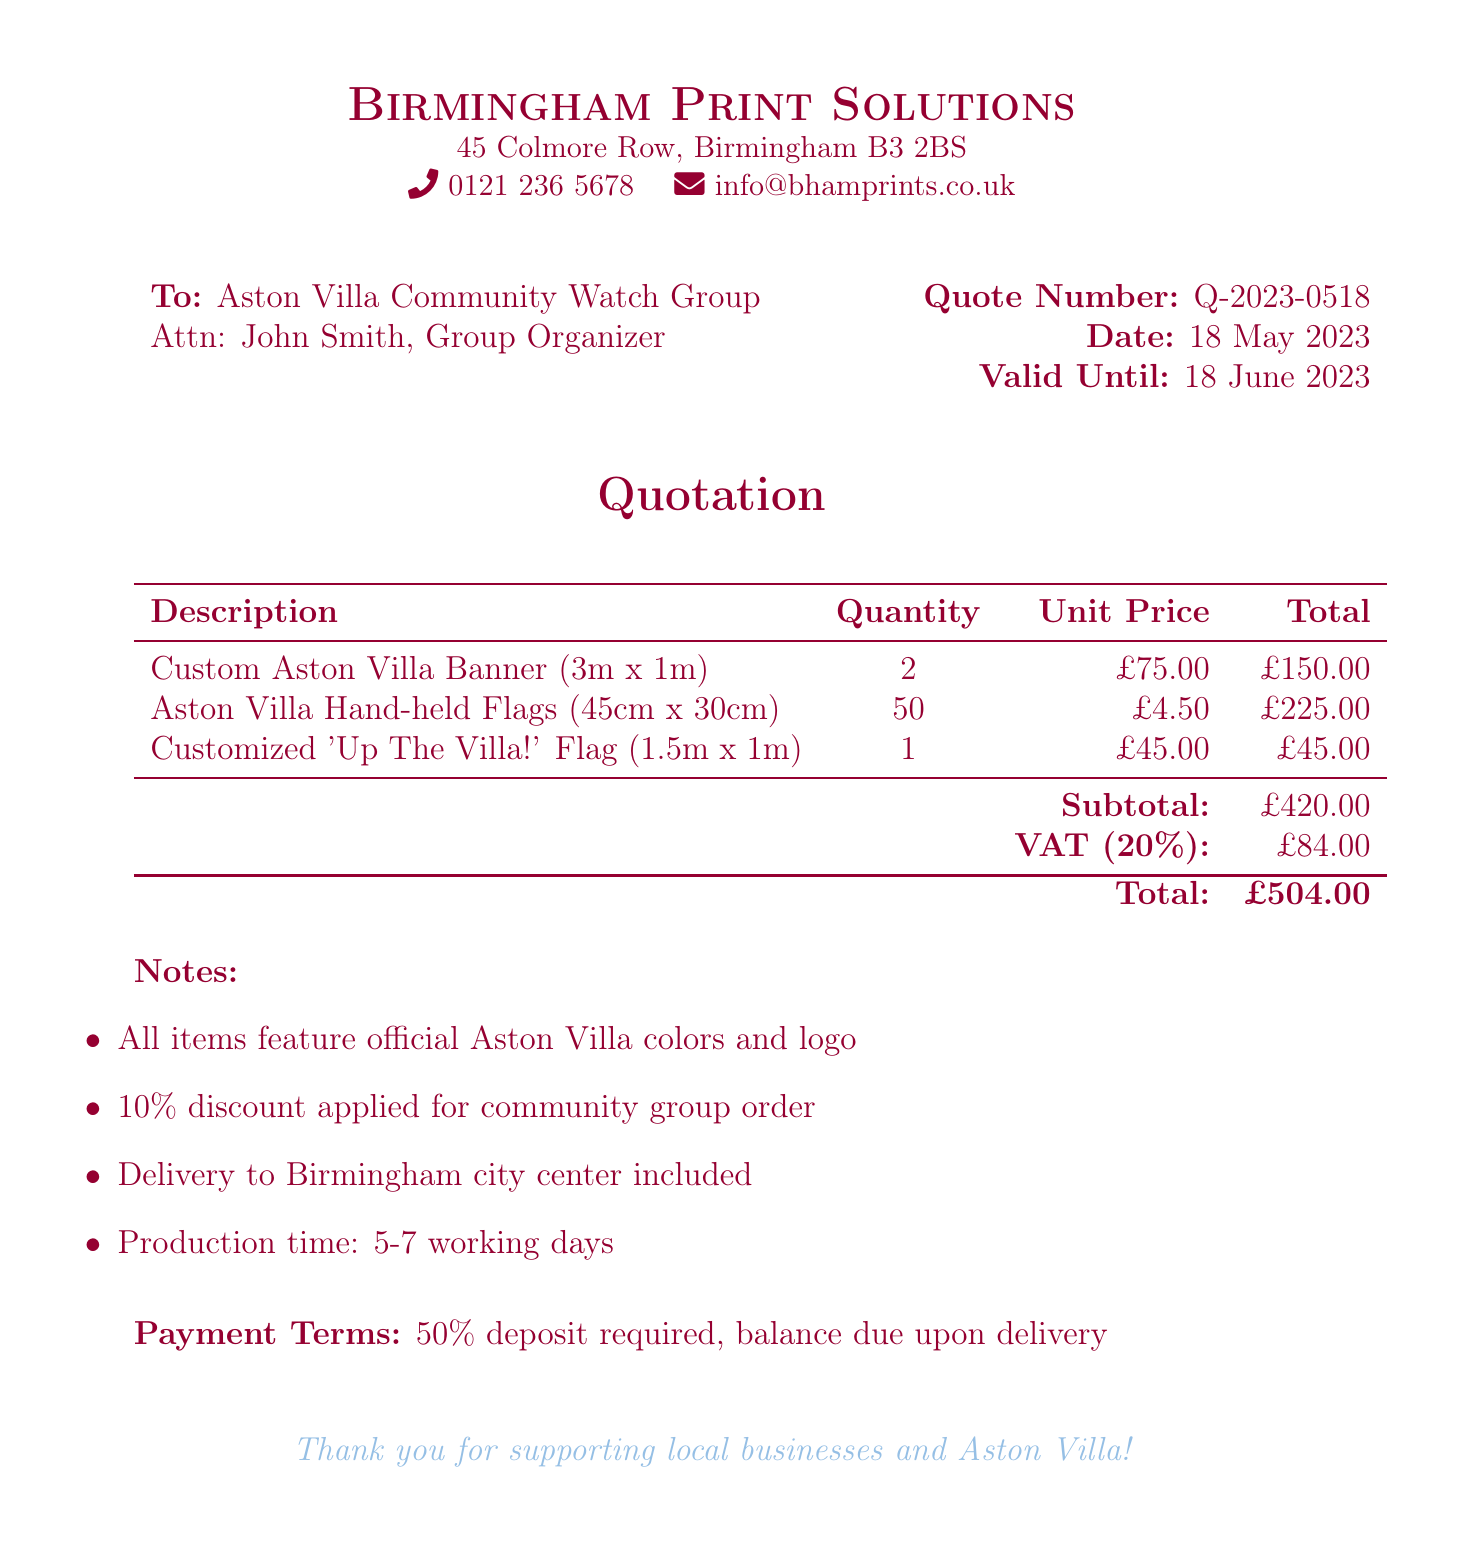What is the quote number? The quote number is stated at the top of the quotation section and identifies this specific quote.
Answer: Q-2023-0518 Who is the quote addressed to? The quote is addressed to the Aston Villa Community Watch Group, specifically to John Smith, the group organizer.
Answer: Aston Villa Community Watch Group What is the subtotal amount? The subtotal amount is listed before the VAT is calculated and is the sum of the total costs of the items.
Answer: £420.00 What percentage is the VAT? The VAT percentage is explicitly mentioned in the document, indicating the rate applied to the subtotal.
Answer: 20% How many hand-held flags are being ordered? The quantity of hand-held flags is clearly specified in the list of items for the order.
Answer: 50 What is the total cost including VAT? The total cost combines the subtotal and the VAT, which is provided at the bottom of the pricing table.
Answer: £504.00 What is the production time stated in the document? The production time is mentioned in the notes section and indicates how long it will take to produce the items.
Answer: 5-7 working days What discount rate was applied to the order? The discount rate is mentioned as a note in the quotation and reflects a special offering for community organizations.
Answer: 10% What is the delivery location for the order? The delivery location is specified in the notes and indicates where the items will be delivered.
Answer: Birmingham city center 